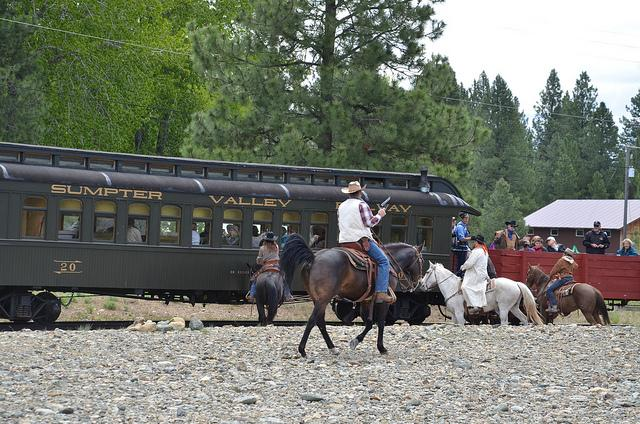What are the men on horses dressed as?

Choices:
A) cowboys
B) indians
C) police
D) ghosts cowboys 